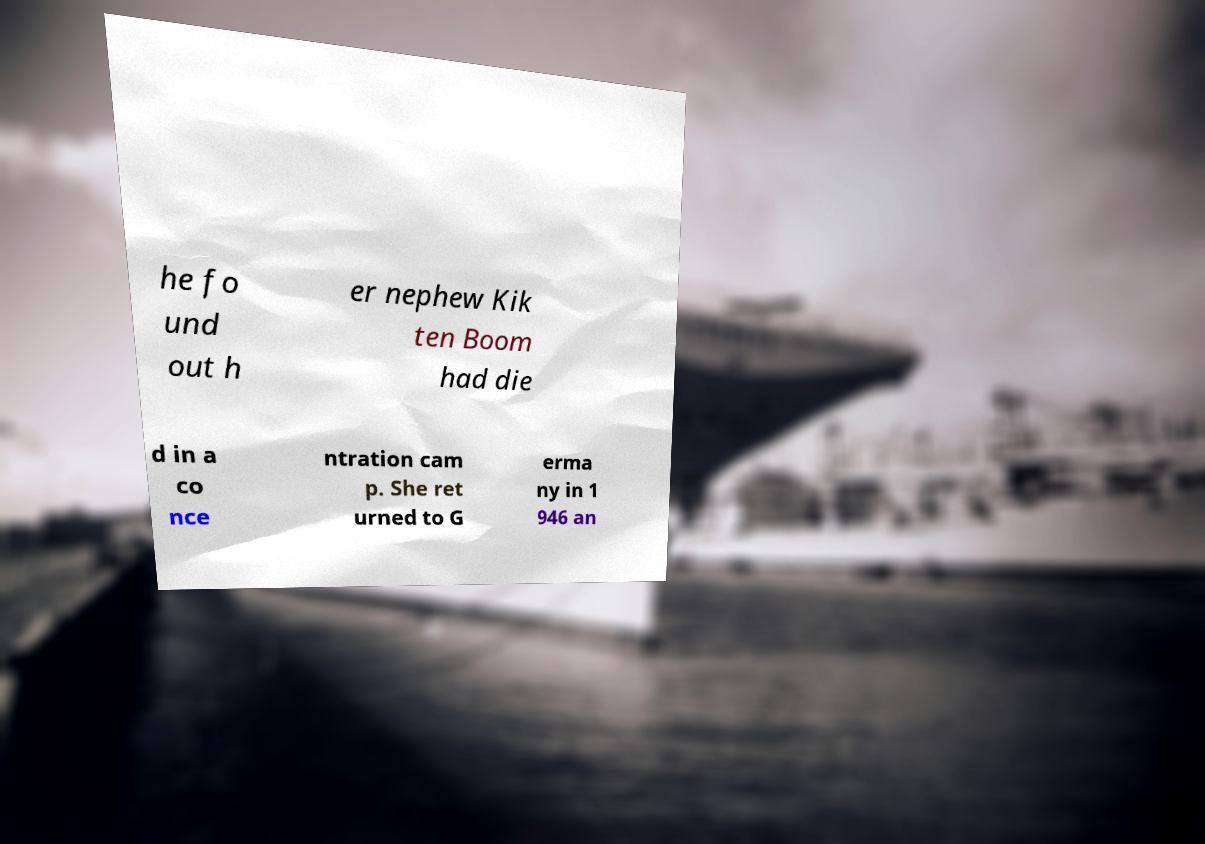Could you extract and type out the text from this image? he fo und out h er nephew Kik ten Boom had die d in a co nce ntration cam p. She ret urned to G erma ny in 1 946 an 